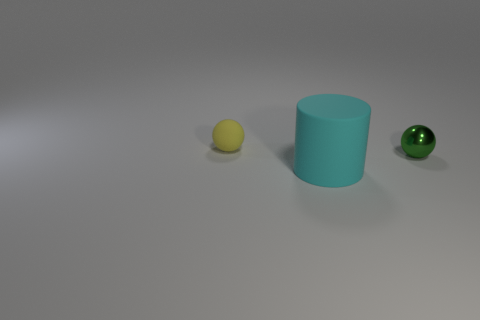The shiny thing that is the same size as the yellow ball is what shape?
Your answer should be compact. Sphere. How many things are either things left of the metal thing or metallic things?
Provide a succinct answer. 3. How many other things are made of the same material as the cyan cylinder?
Your answer should be very brief. 1. How big is the matte thing that is in front of the yellow thing?
Ensure brevity in your answer.  Large. What is the shape of the object that is made of the same material as the yellow sphere?
Your response must be concise. Cylinder. Does the big thing have the same material as the small object that is on the left side of the large cyan cylinder?
Make the answer very short. Yes. There is a tiny object in front of the yellow sphere; does it have the same shape as the small yellow matte object?
Give a very brief answer. Yes. There is another object that is the same shape as the metallic object; what is its material?
Your answer should be compact. Rubber. Is the shape of the metallic object the same as the object behind the green ball?
Ensure brevity in your answer.  Yes. What is the color of the object that is to the left of the green metallic ball and behind the big cyan rubber object?
Your response must be concise. Yellow. 